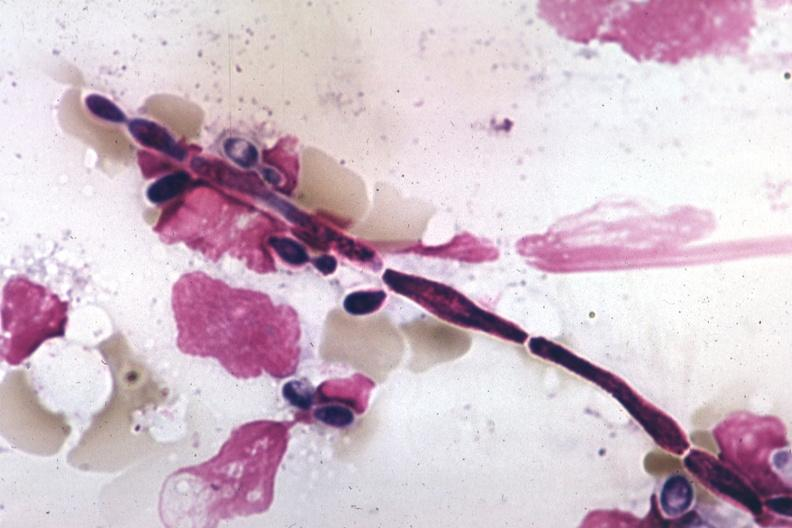what does this image show?
Answer the question using a single word or phrase. Pseudohyphal forms 